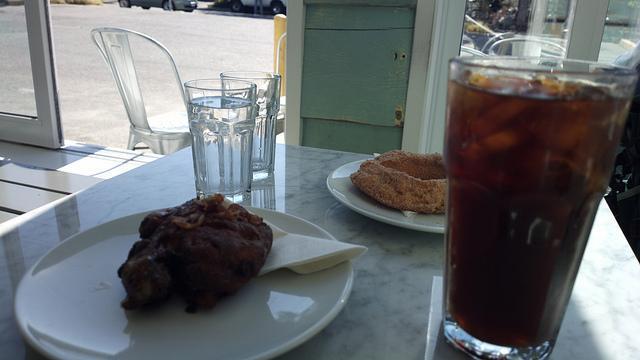Does the image validate the caption "The donut is at the side of the dining table."?
Answer yes or no. Yes. 